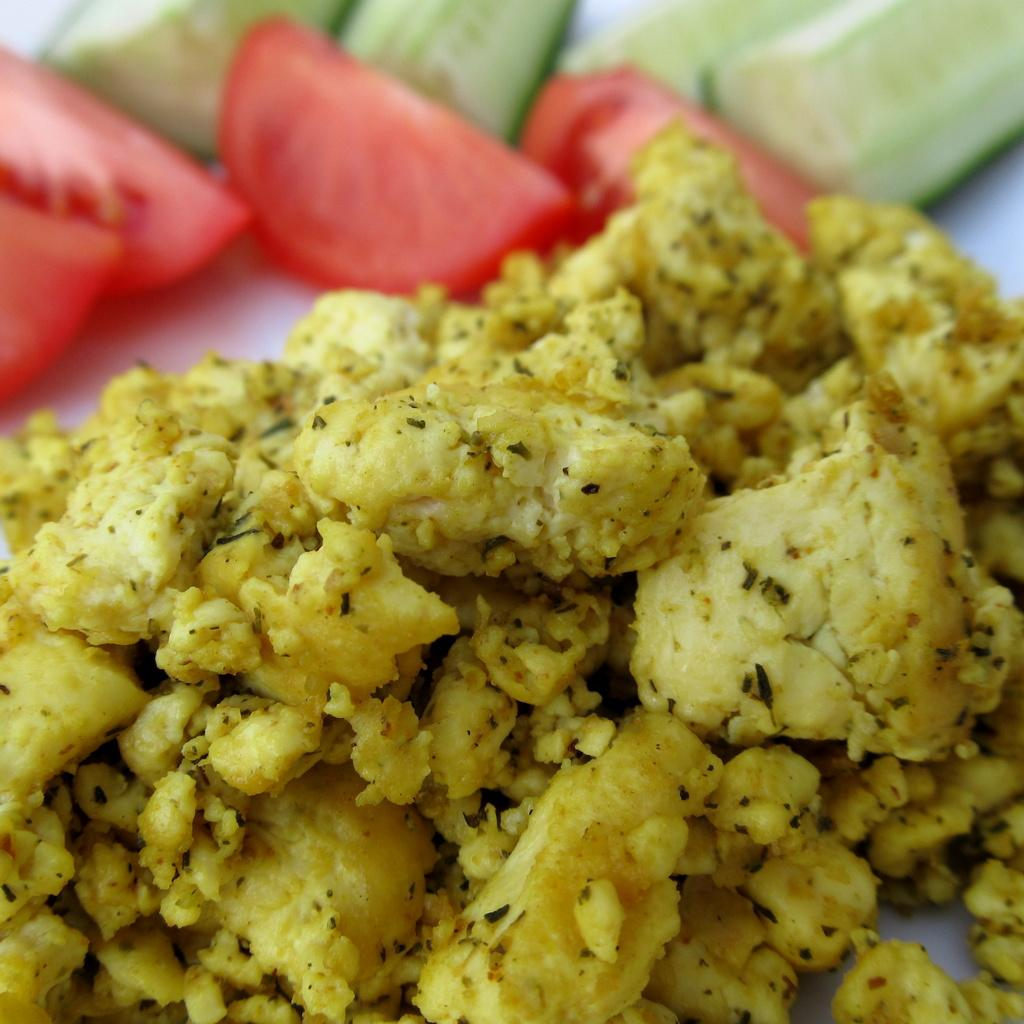What is the main subject in the foreground of the image? There is a food item in the foreground of the image. What is the color of the surface on which the food item is placed? The food item is on a white surface. What can be seen at the top of the image? There are cut vegetables at the top of the image. How many men are standing on the shelf in the image? There are no men or shelves present in the image. 